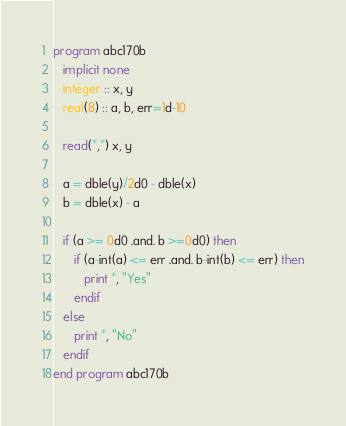Convert code to text. <code><loc_0><loc_0><loc_500><loc_500><_FORTRAN_>program abc170b
   implicit none
   integer :: x, y
   real(8) :: a, b, err=1d-10

   read(*,*) x, y

   a = dble(y)/2d0 - dble(x)
   b = dble(x) - a

   if (a >= 0d0 .and. b >=0d0) then
      if (a-int(a) <= err .and. b-int(b) <= err) then
         print *, "Yes"
      endif
   else
      print *, "No"
   endif
end program abc170b
</code> 